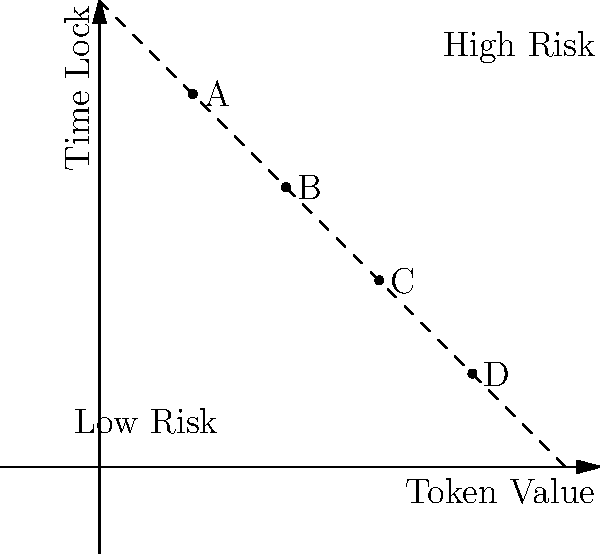In a blockchain-based trading platform, four financial instruments (A, B, C, and D) are arranged based on their token value and time lock period. Given the spatial arrangement shown in the diagram, which instrument would be considered the least risky for investors? To determine the least risky financial instrument, we need to analyze the spatial arrangement based on two factors: token value and time lock period. Here's a step-by-step explanation:

1. Understand the axes:
   - X-axis represents Token Value (increasing from left to right)
   - Y-axis represents Time Lock period (increasing from bottom to top)

2. Interpret the risk factors:
   - Higher token value generally indicates lower risk
   - Shorter time lock periods are usually associated with lower risk

3. Analyze the position of each instrument:
   - A: Low token value, high time lock
   - B: Medium-low token value, medium-high time lock
   - C: Medium-high token value, medium-low time lock
   - D: High token value, low time lock

4. Consider the risk boundary:
   - The dashed line represents a risk boundary
   - Instruments closer to the bottom-right corner are less risky

5. Compare the instruments:
   - D is positioned closest to the bottom-right corner
   - D has the highest token value and shortest time lock period

Therefore, based on the spatial arrangement, instrument D would be considered the least risky for investors in this blockchain-based trading platform.
Answer: D 